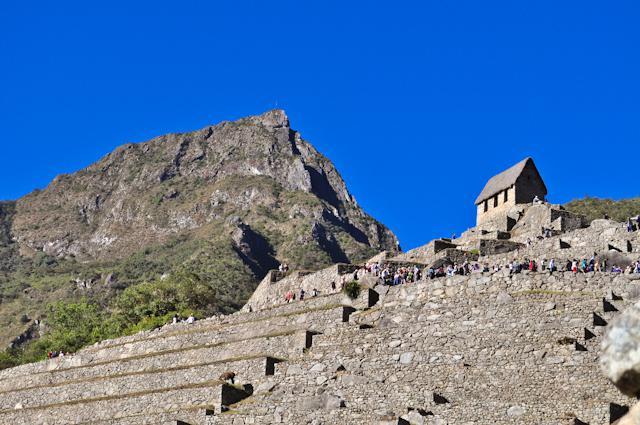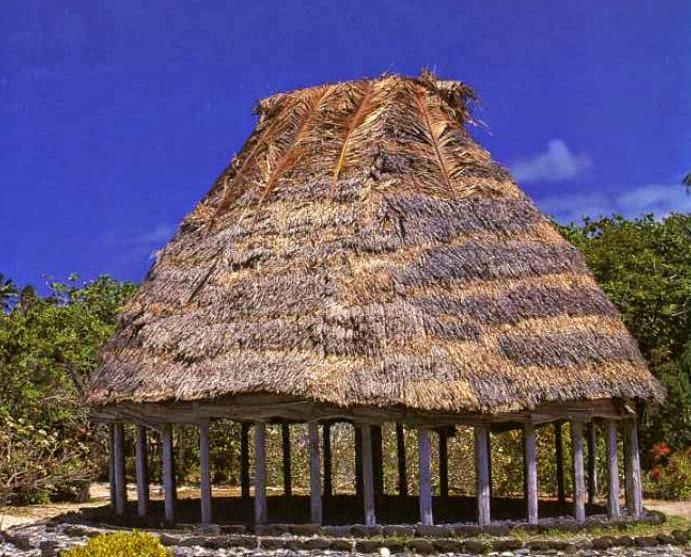The first image is the image on the left, the second image is the image on the right. Given the left and right images, does the statement "The left image features a simple peaked thatch roof with a small projection at the top, and the right image features at least one animal figure on the edge of a peaked roof with diamond 'stitched' border." hold true? Answer yes or no. No. The first image is the image on the left, the second image is the image on the right. Considering the images on both sides, is "At least one animal is standing on the roof in the image on the right." valid? Answer yes or no. No. 